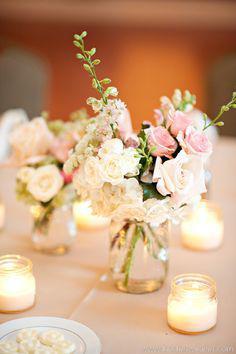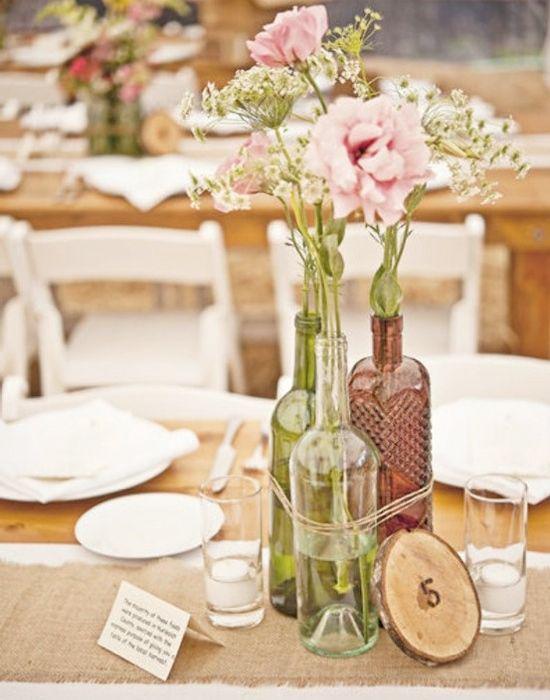The first image is the image on the left, the second image is the image on the right. For the images displayed, is the sentence "There are 3 non-clear vases." factually correct? Answer yes or no. No. 